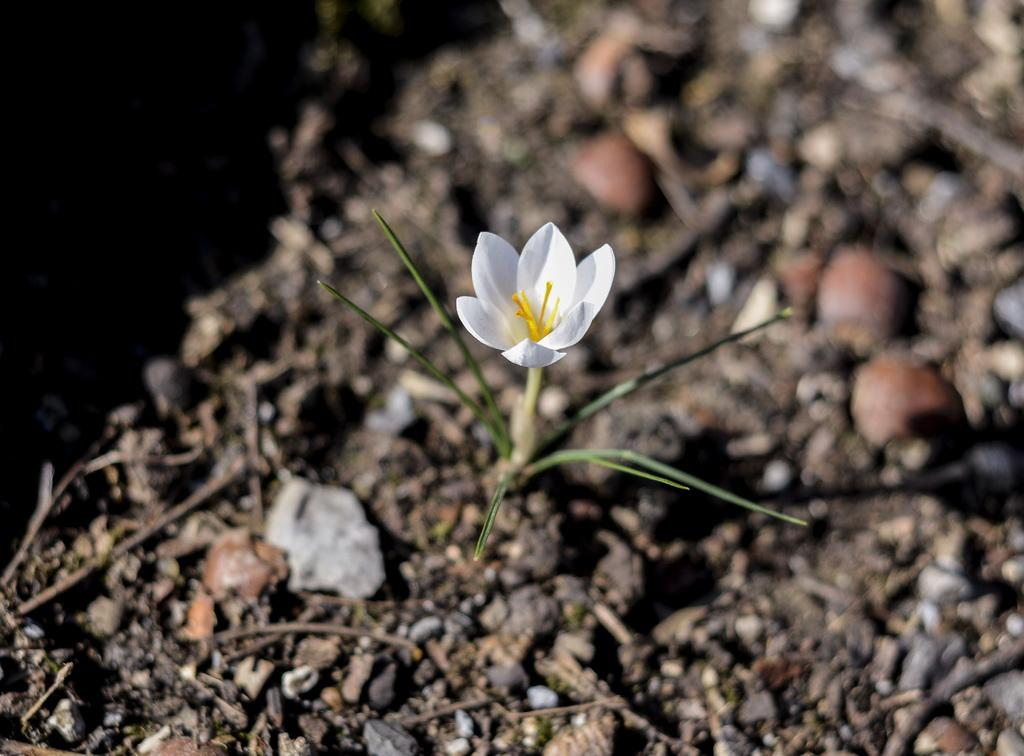What type of plant can be seen in the image? There is a flowering plant in the image. What else is on the ground in the image besides the plant? Stones and sticks are on the ground in the image. Can you tell if the image was taken during the day or night? The image was likely taken during the day. What type of fruit is hanging from the flowering plant in the image? There is no fruit visible on the flowering plant in the image. How many cattle can be seen grazing in the background of the image? There are no cattle present in the image. 